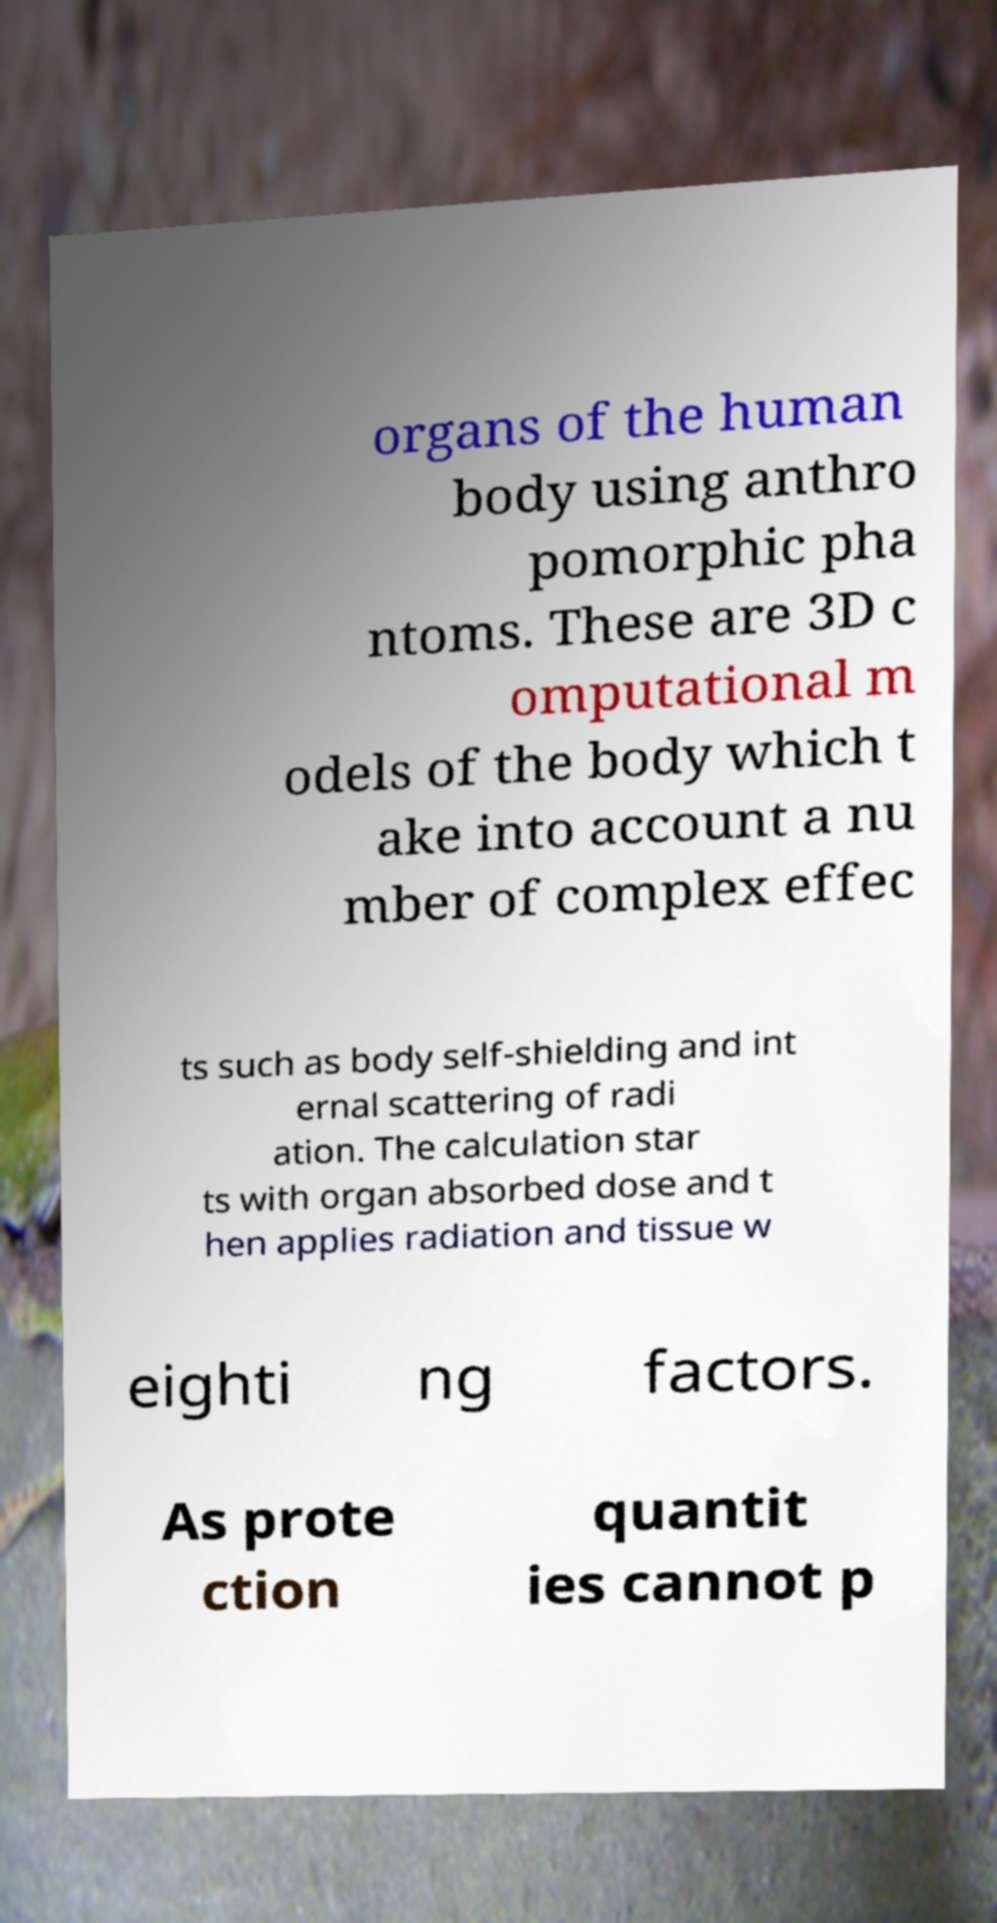Could you extract and type out the text from this image? organs of the human body using anthro pomorphic pha ntoms. These are 3D c omputational m odels of the body which t ake into account a nu mber of complex effec ts such as body self-shielding and int ernal scattering of radi ation. The calculation star ts with organ absorbed dose and t hen applies radiation and tissue w eighti ng factors. As prote ction quantit ies cannot p 